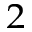<formula> <loc_0><loc_0><loc_500><loc_500>_ { 2 }</formula> 